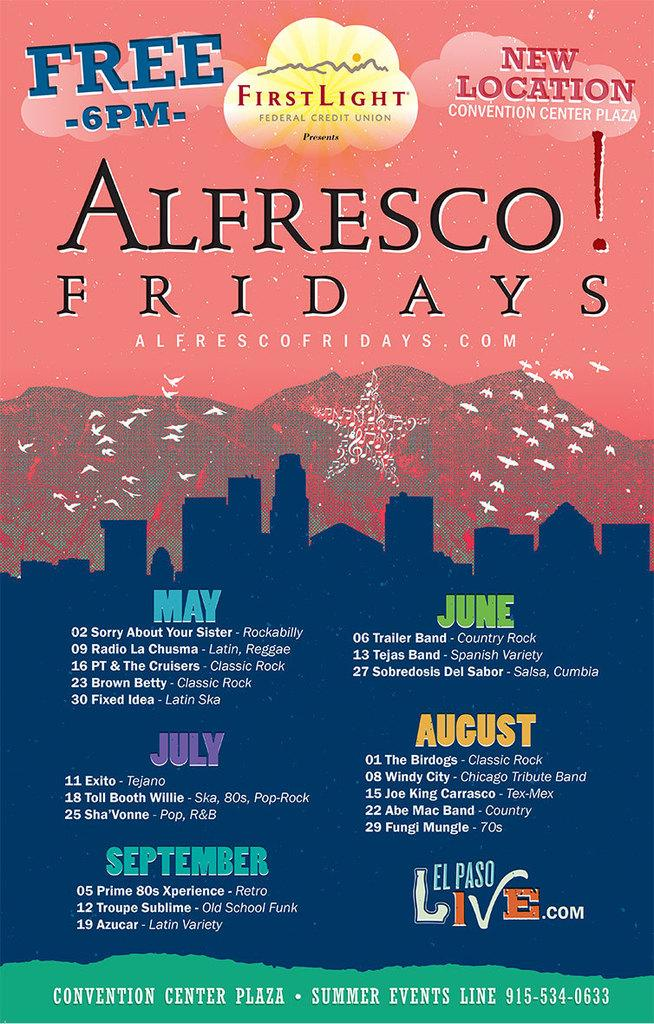<image>
Relay a brief, clear account of the picture shown. First Light Federal Credit Union advertises Alfresco Fridays. 